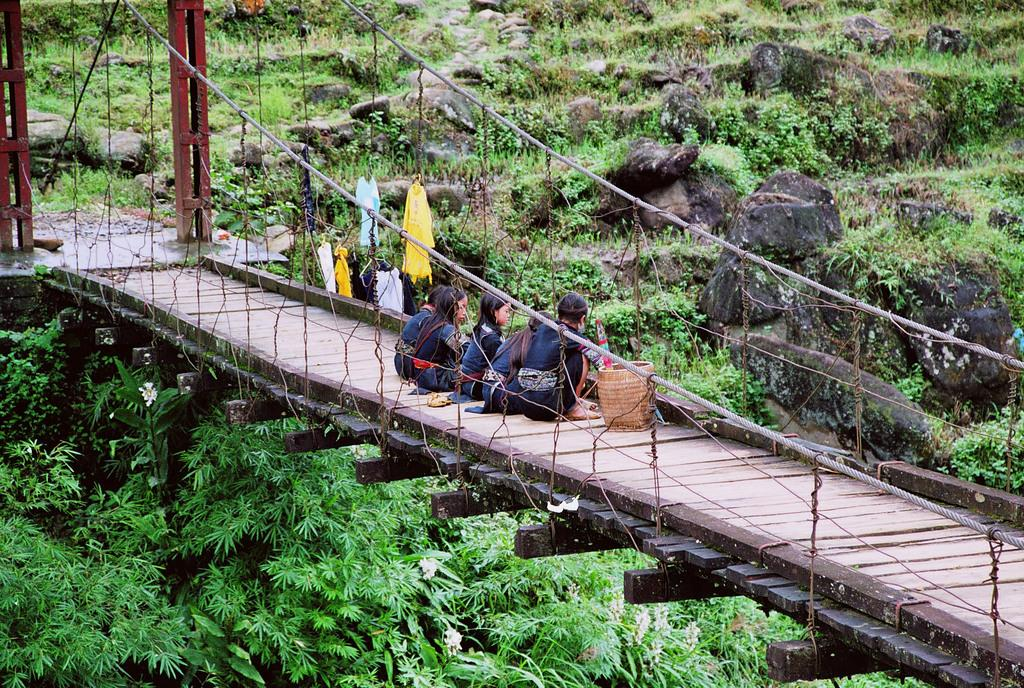What are the people in the image doing? The people in the image are sitting on the bridge. What object is beside the people on the bridge? There is a basket beside the people. What is hanging on the net in the image? There are clothes on a net. What type of vegetation can be seen in the image? Trees are visible in the image. What can be seen in the background of the image? There is grass in the background of the image. What type of pin can be seen holding the clothes on the net? There is no pin visible in the image; the clothes are hanging on a net. What activity is the crook performing in the image? There is no crook present in the image, so no such activity can be observed. 